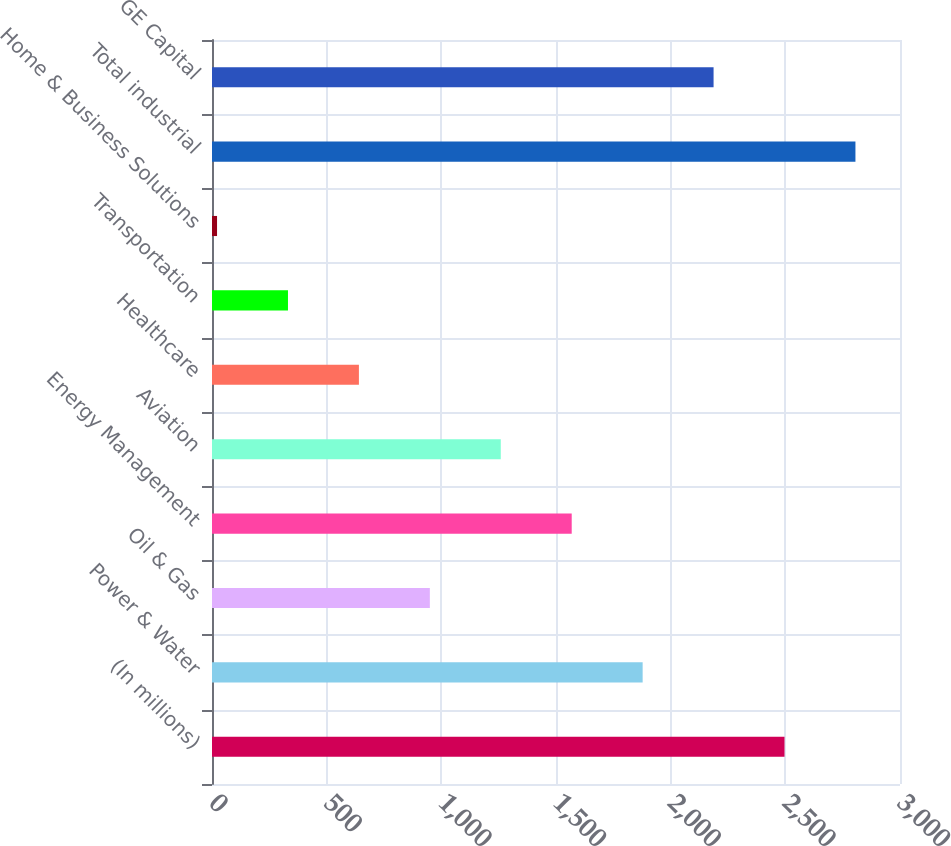<chart> <loc_0><loc_0><loc_500><loc_500><bar_chart><fcel>(In millions)<fcel>Power & Water<fcel>Oil & Gas<fcel>Energy Management<fcel>Aviation<fcel>Healthcare<fcel>Transportation<fcel>Home & Business Solutions<fcel>Total industrial<fcel>GE Capital<nl><fcel>2496.4<fcel>1877.8<fcel>949.9<fcel>1568.5<fcel>1259.2<fcel>640.6<fcel>331.3<fcel>22<fcel>2805.7<fcel>2187.1<nl></chart> 